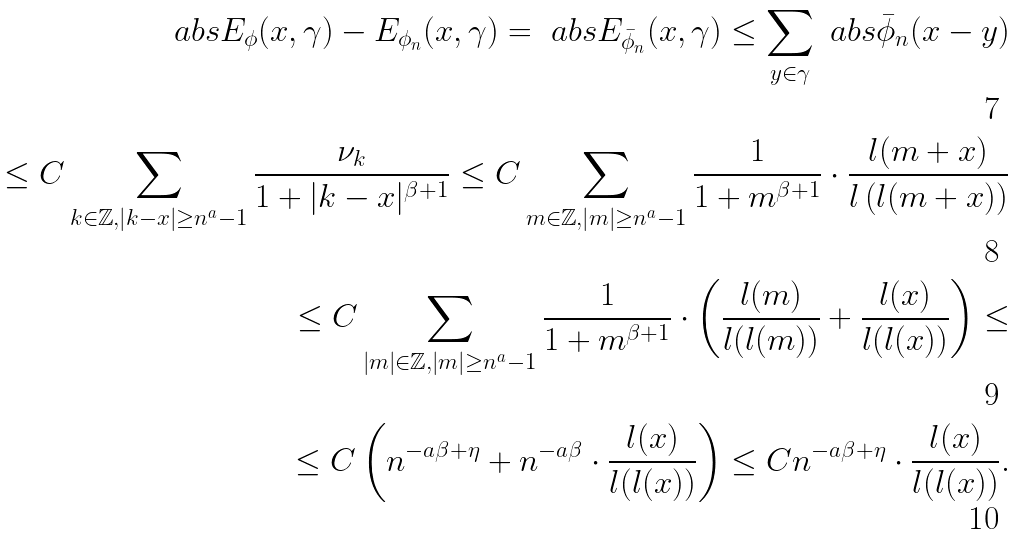Convert formula to latex. <formula><loc_0><loc_0><loc_500><loc_500>\ a b s { E _ { \phi } ( x , \gamma ) - E _ { \phi _ { n } } ( x , \gamma ) } = \ a b s { E _ { \bar { \phi } _ { n } } ( x , \gamma ) } \leq \sum _ { y \in \gamma } \ a b s { \bar { \phi } _ { n } ( x - y ) } \\ \leq C \sum _ { k \in \mathbb { Z } , | k - x | \geq n ^ { a } - 1 } \frac { \nu _ { k } } { 1 + | k - x | ^ { \beta + 1 } } \leq C \sum _ { m \in \mathbb { Z } , | m | \geq n ^ { a } - 1 } \frac { 1 } { 1 + m ^ { \beta + 1 } } \cdot \frac { l ( m + x ) } { l \left ( l ( m + x ) \right ) } \\ \leq C \sum _ { | m | \in \mathbb { Z } , | m | \geq n ^ { a } - 1 } \frac { 1 } { 1 + m ^ { \beta + 1 } } \cdot \left ( \frac { l ( m ) } { l ( l ( m ) ) } + \frac { l ( x ) } { l ( l ( x ) ) } \right ) \leq \\ \leq C \left ( n ^ { - a \beta + \eta } + n ^ { - a \beta } \cdot \frac { l ( x ) } { l ( l ( x ) ) } \right ) \leq C n ^ { - a \beta + \eta } \cdot \frac { l ( x ) } { l ( l ( x ) ) } .</formula> 